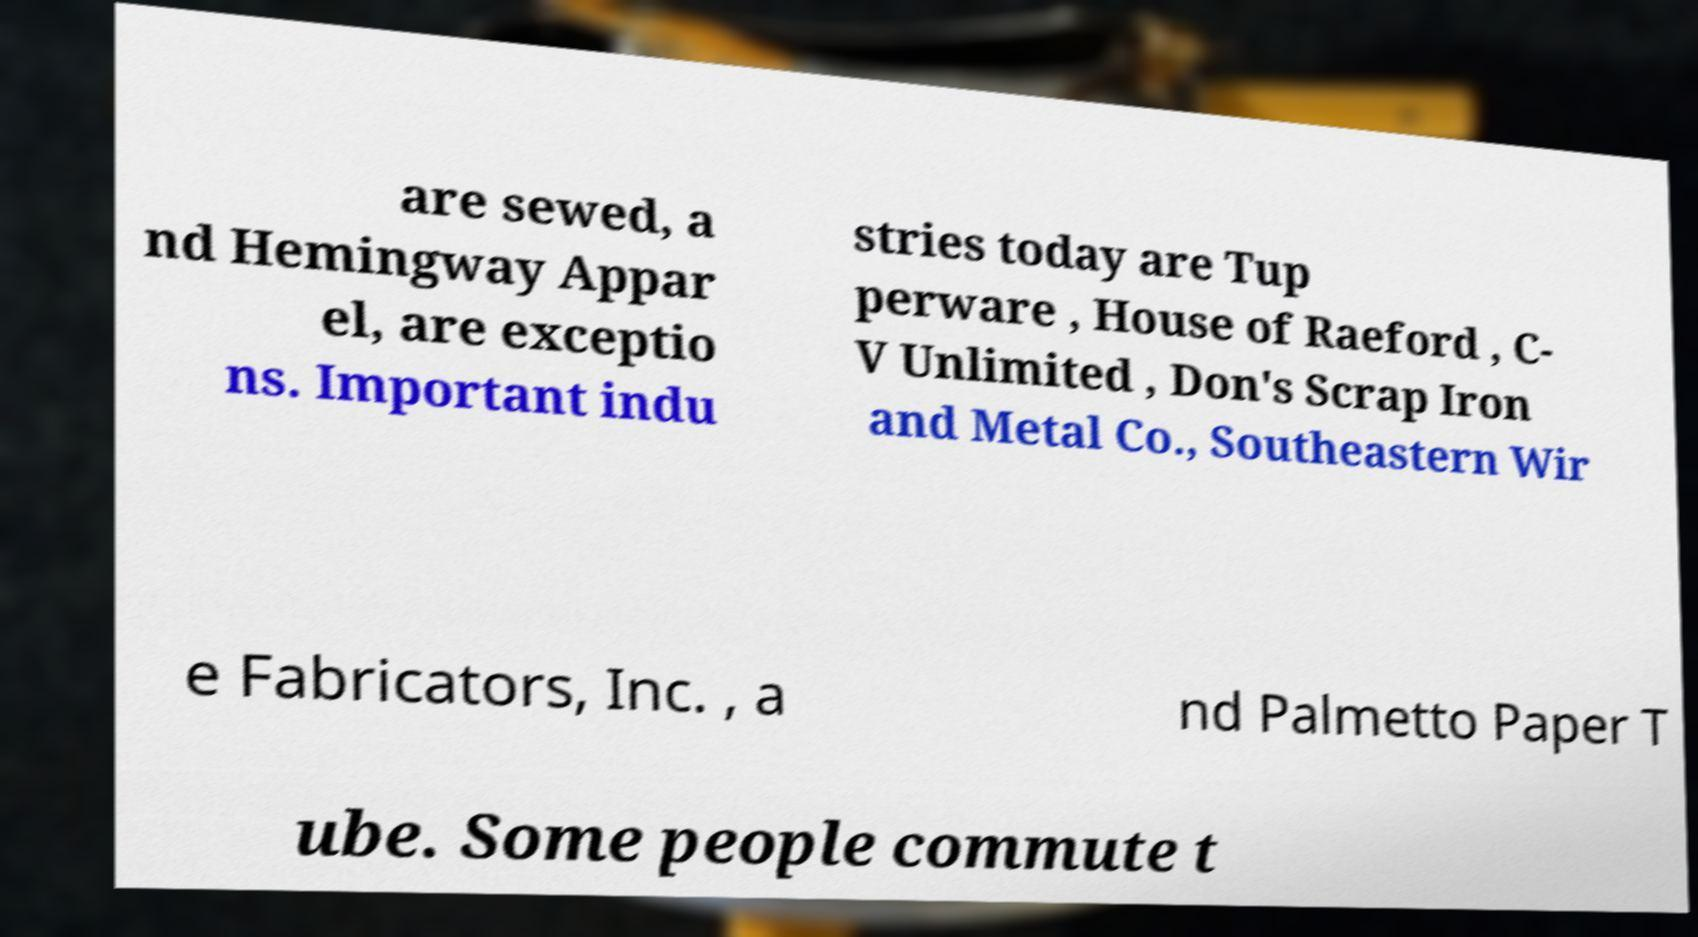Please read and relay the text visible in this image. What does it say? are sewed, a nd Hemingway Appar el, are exceptio ns. Important indu stries today are Tup perware , House of Raeford , C- V Unlimited , Don's Scrap Iron and Metal Co., Southeastern Wir e Fabricators, Inc. , a nd Palmetto Paper T ube. Some people commute t 